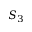Convert formula to latex. <formula><loc_0><loc_0><loc_500><loc_500>S _ { 3 }</formula> 